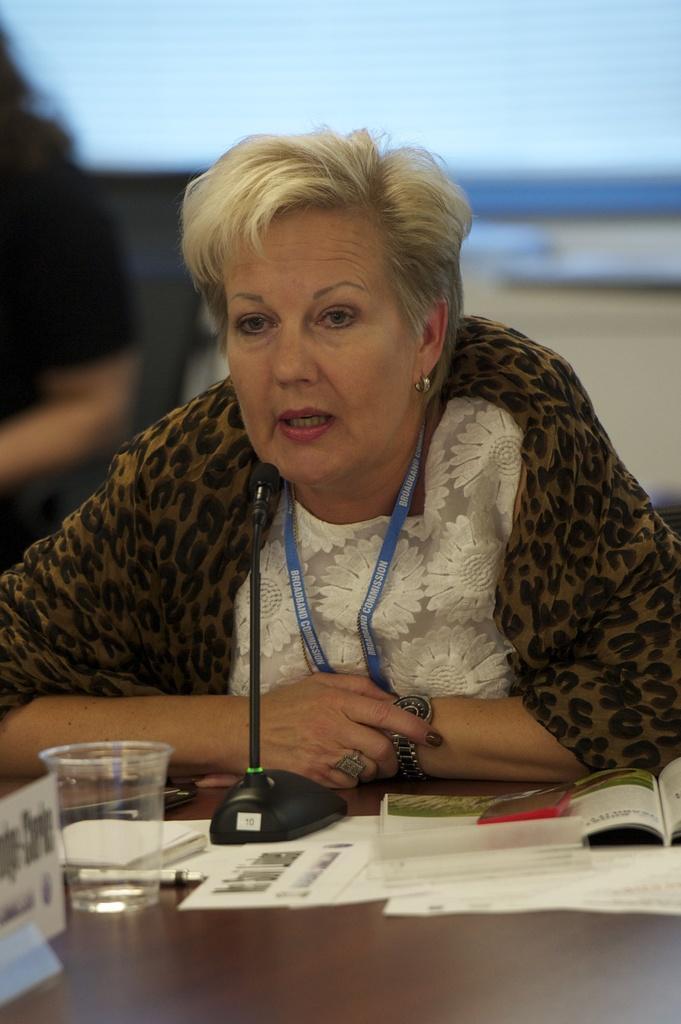In one or two sentences, can you explain what this image depicts? This picture shows a woman seated and speaking with the help of a microphone and we see some papers and a glass on the table. 